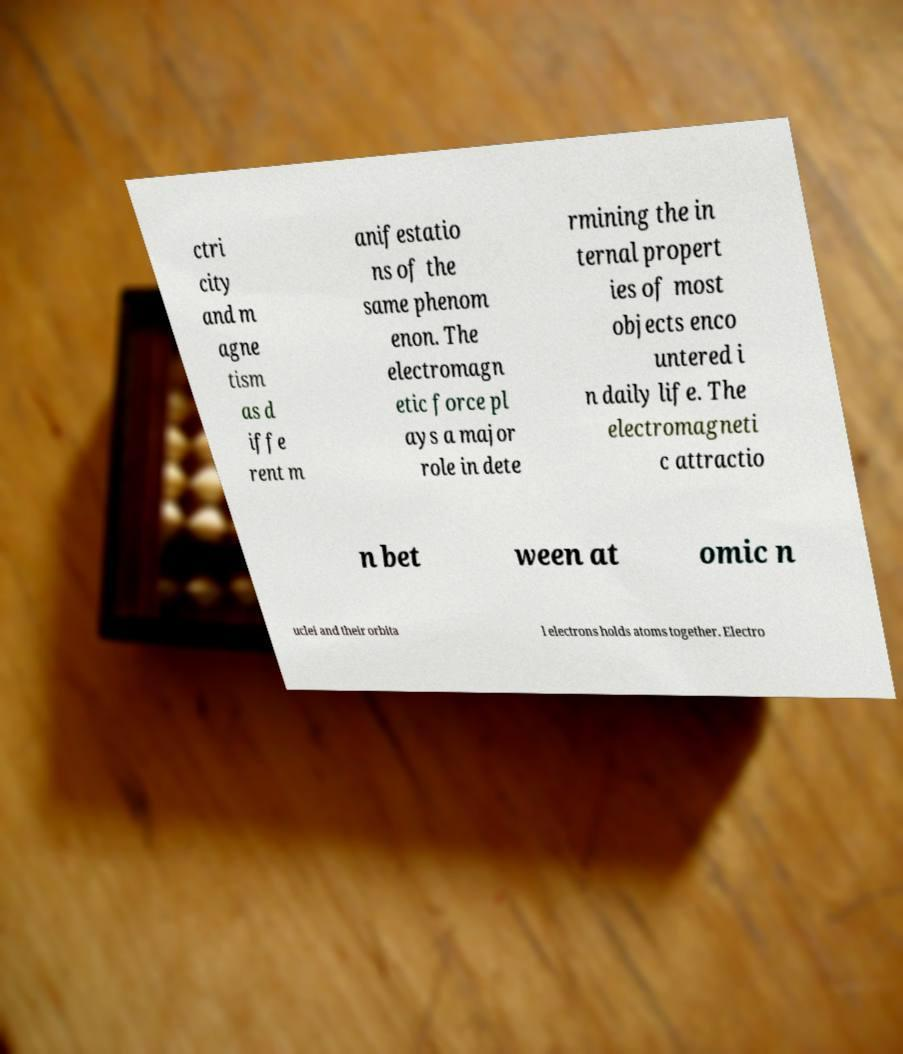There's text embedded in this image that I need extracted. Can you transcribe it verbatim? ctri city and m agne tism as d iffe rent m anifestatio ns of the same phenom enon. The electromagn etic force pl ays a major role in dete rmining the in ternal propert ies of most objects enco untered i n daily life. The electromagneti c attractio n bet ween at omic n uclei and their orbita l electrons holds atoms together. Electro 